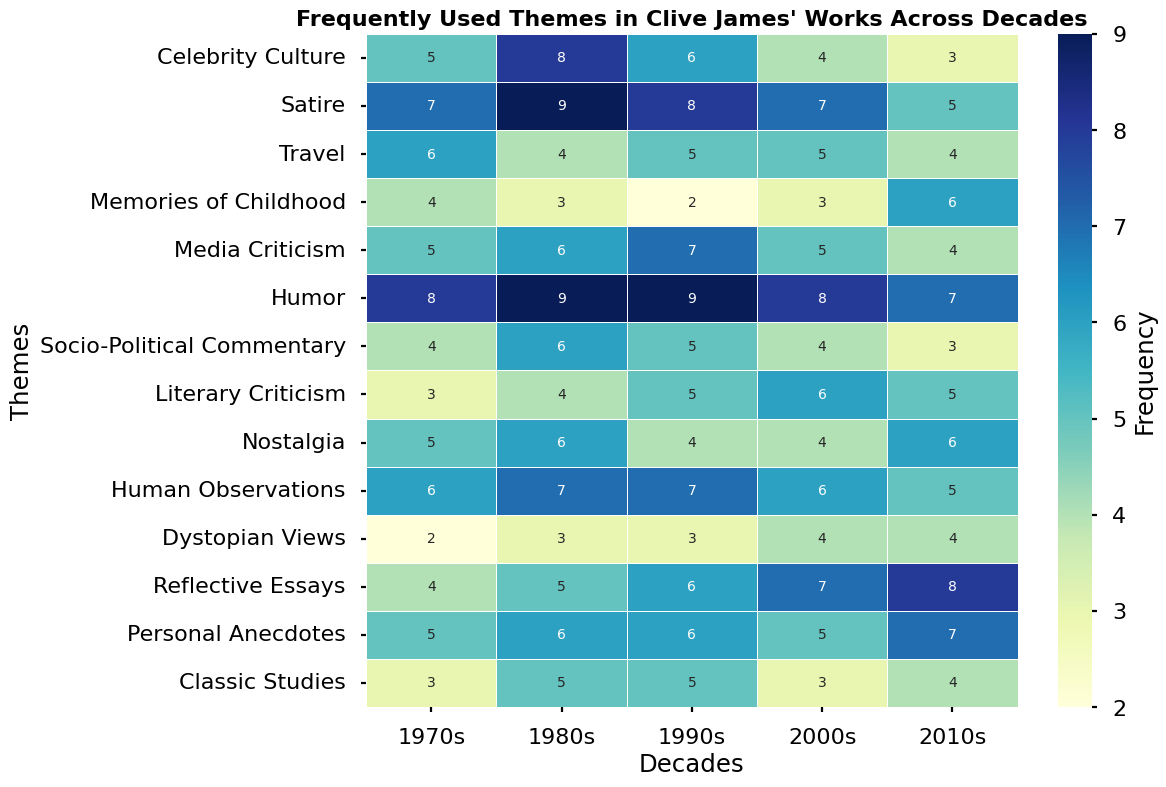What is the most frequently used theme in Clive James' works in the 1980s? The theme with the highest frequency count in the 1980s column is "Humor", with a count of 9.
Answer: Humor Which decade has the highest frequency for the theme "Reflective Essays"? By comparing the "Reflective Essays" row, the 2010s have the highest count of 8.
Answer: 2010s Compare the count of the theme "Media Criticism" in the 1990s to "Celebrity Culture" in the same decade. Which theme has a higher count? In the 1990s column, "Media Criticism" has a count of 7 and "Celebrity Culture" has a count of 6, so "Media Criticism" is higher.
Answer: Media Criticism Among the themes in the 2000s, which has the lowest frequency? In the 2000s column, "Celebrity Culture" and "Classic Studies" both have the lowest count of 3.
Answer: Celebrity Culture and Classic Studies What is the average frequency of the theme "Humor" across all the decades? The counts for "Humor" are 8, 9, 9, 8, and 7 across the decades. Adding these together: 8 + 9 + 9 + 8 + 7 = 41, then divide by 5 (the number of decades): 41 / 5 = 8.2.
Answer: 8.2 Which theme has shown the most consistent frequency (least variation) across the decades? "Travel" has frequencies 6, 4, 5, 5, and 4. The range is 6 - 4 = 2. Checking other themes' ranges shows higher variations, making "Travel" the most consistent.
Answer: Travel What is the visual trend for the theme "Personal Anecdotes"? The frequency of "Personal Anecdotes" starts at 5 in the 1970s, increases to 6 in the 1980s and 1990s, returns to 5 in the 2000s, and peaks at 7 in the 2010s. This indicates a rising trend over time.
Answer: Increasing trend Which theme saw the biggest increase in frequency from the 1990s to the 2010s? By calculating the increase, "Reflective Essays" increased from 6 in the 1990s to 8 in the 2010s, an increase of 2, which is the largest among the themes.
Answer: Reflective Essays How many themes have a peak frequency in the 1970s? Themes with their highest count in the 1970s column are "Travel" (6), "Dystopian Views" (2), and "Human Observations" (6). There are 3 such themes.
Answer: 3 